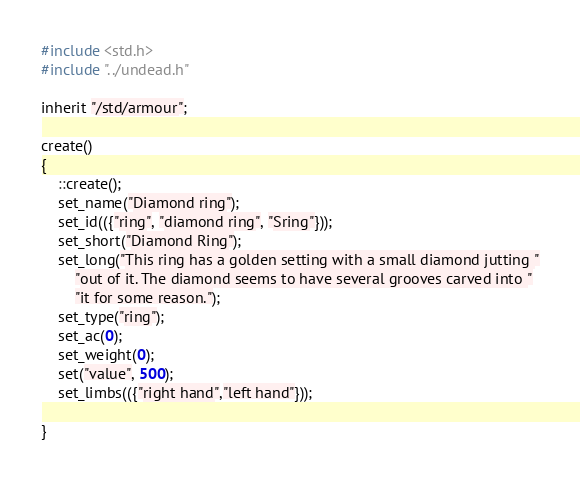Convert code to text. <code><loc_0><loc_0><loc_500><loc_500><_C_>#include <std.h>
#include "../undead.h"

inherit "/std/armour";

create() 
{
    ::create();
    set_name("Diamond ring");
    set_id(({"ring", "diamond ring", "Sring"}));
    set_short("Diamond Ring");
    set_long("This ring has a golden setting with a small diamond jutting "
        "out of it. The diamond seems to have several grooves carved into "
        "it for some reason.");
    set_type("ring");
    set_ac(0);
    set_weight(0);
    set("value", 500);
    set_limbs(({"right hand","left hand"}));

}
</code> 